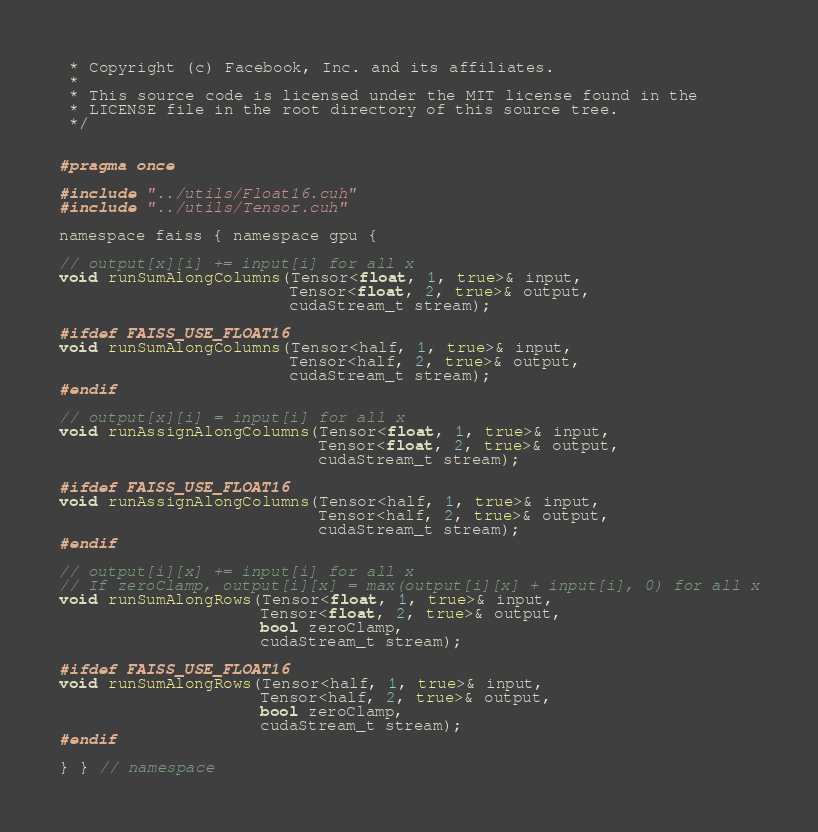Convert code to text. <code><loc_0><loc_0><loc_500><loc_500><_Cuda_> * Copyright (c) Facebook, Inc. and its affiliates.
 *
 * This source code is licensed under the MIT license found in the
 * LICENSE file in the root directory of this source tree.
 */


#pragma once

#include "../utils/Float16.cuh"
#include "../utils/Tensor.cuh"

namespace faiss { namespace gpu {

// output[x][i] += input[i] for all x
void runSumAlongColumns(Tensor<float, 1, true>& input,
                        Tensor<float, 2, true>& output,
                        cudaStream_t stream);

#ifdef FAISS_USE_FLOAT16
void runSumAlongColumns(Tensor<half, 1, true>& input,
                        Tensor<half, 2, true>& output,
                        cudaStream_t stream);
#endif

// output[x][i] = input[i] for all x
void runAssignAlongColumns(Tensor<float, 1, true>& input,
                           Tensor<float, 2, true>& output,
                           cudaStream_t stream);

#ifdef FAISS_USE_FLOAT16
void runAssignAlongColumns(Tensor<half, 1, true>& input,
                           Tensor<half, 2, true>& output,
                           cudaStream_t stream);
#endif

// output[i][x] += input[i] for all x
// If zeroClamp, output[i][x] = max(output[i][x] + input[i], 0) for all x
void runSumAlongRows(Tensor<float, 1, true>& input,
                     Tensor<float, 2, true>& output,
                     bool zeroClamp,
                     cudaStream_t stream);

#ifdef FAISS_USE_FLOAT16
void runSumAlongRows(Tensor<half, 1, true>& input,
                     Tensor<half, 2, true>& output,
                     bool zeroClamp,
                     cudaStream_t stream);
#endif

} } // namespace
</code> 